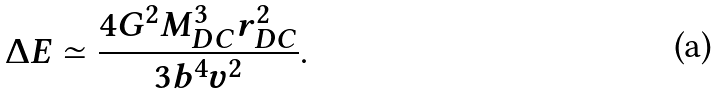Convert formula to latex. <formula><loc_0><loc_0><loc_500><loc_500>\Delta E \simeq \frac { 4 G ^ { 2 } M _ { D C } ^ { 3 } r _ { D C } ^ { 2 } } { 3 b ^ { 4 } v ^ { 2 } } .</formula> 